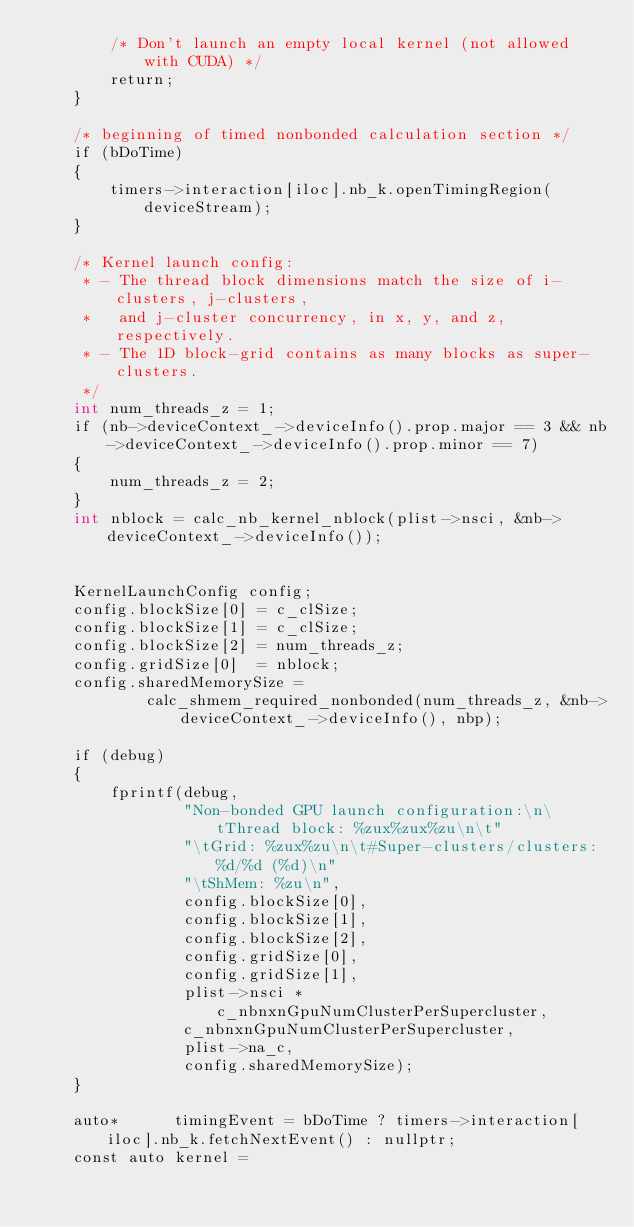Convert code to text. <code><loc_0><loc_0><loc_500><loc_500><_Cuda_>        /* Don't launch an empty local kernel (not allowed with CUDA) */
        return;
    }

    /* beginning of timed nonbonded calculation section */
    if (bDoTime)
    {
        timers->interaction[iloc].nb_k.openTimingRegion(deviceStream);
    }

    /* Kernel launch config:
     * - The thread block dimensions match the size of i-clusters, j-clusters,
     *   and j-cluster concurrency, in x, y, and z, respectively.
     * - The 1D block-grid contains as many blocks as super-clusters.
     */
    int num_threads_z = 1;
    if (nb->deviceContext_->deviceInfo().prop.major == 3 && nb->deviceContext_->deviceInfo().prop.minor == 7)
    {
        num_threads_z = 2;
    }
    int nblock = calc_nb_kernel_nblock(plist->nsci, &nb->deviceContext_->deviceInfo());


    KernelLaunchConfig config;
    config.blockSize[0] = c_clSize;
    config.blockSize[1] = c_clSize;
    config.blockSize[2] = num_threads_z;
    config.gridSize[0]  = nblock;
    config.sharedMemorySize =
            calc_shmem_required_nonbonded(num_threads_z, &nb->deviceContext_->deviceInfo(), nbp);

    if (debug)
    {
        fprintf(debug,
                "Non-bonded GPU launch configuration:\n\tThread block: %zux%zux%zu\n\t"
                "\tGrid: %zux%zu\n\t#Super-clusters/clusters: %d/%d (%d)\n"
                "\tShMem: %zu\n",
                config.blockSize[0],
                config.blockSize[1],
                config.blockSize[2],
                config.gridSize[0],
                config.gridSize[1],
                plist->nsci * c_nbnxnGpuNumClusterPerSupercluster,
                c_nbnxnGpuNumClusterPerSupercluster,
                plist->na_c,
                config.sharedMemorySize);
    }

    auto*      timingEvent = bDoTime ? timers->interaction[iloc].nb_k.fetchNextEvent() : nullptr;
    const auto kernel =</code> 